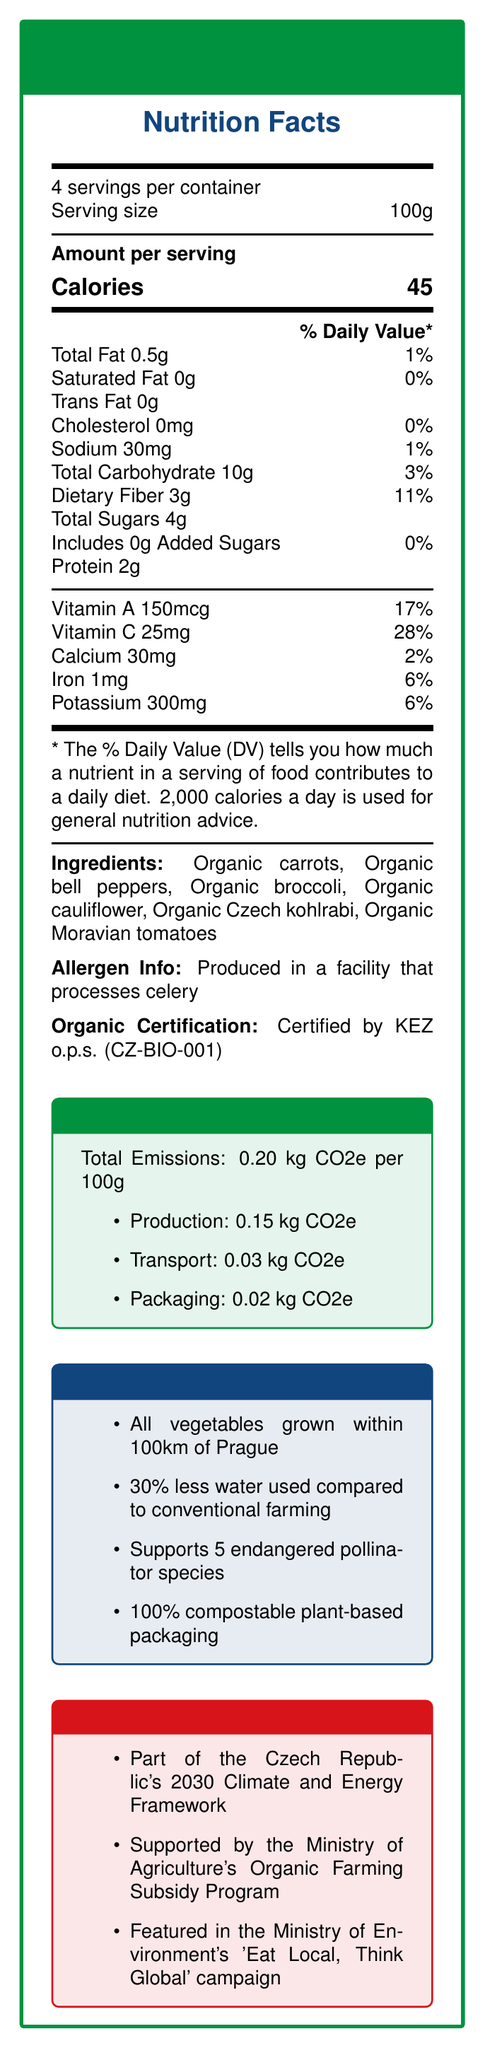what is the serving size for the Czech Eco-Friendly Vegetable Blend? The serving size is explicitly mentioned as 100g under the "4 servings per container" line.
Answer: 100g how many calories are there per serving? The calories per serving are mentioned as 45 in the "Amount per serving" section.
Answer: 45 list the vitamins and minerals provided by the vegetable blend and their respective daily values. The document lists these vitamins and minerals with their % Daily Values in the relevant section.
Answer: Vitamin A 17%, Vitamin C 28%, Calcium 2%, Iron 6%, Potassium 6% which organization certified the blend as organic? The "Organic Certification" information states that it is certified by KEZ o.p.s. (CZ-BIO-001).
Answer: KEZ o.p.s. (CZ-BIO-001) how much carbon dioxide equivalent (CO2e) emissions are produced from packaging per 100g? The "Carbon Footprint" section of the document states packaging emissions as 0.02 kg CO2e per 100g.
Answer: 0.02 kg CO2e what allergens are processed in the facility where the vegetable blend is produced? The "Allergen Info" section states that the product is produced in a facility that processes celery.
Answer: Celery how much dietary fiber is in one serving of the vegetable blend? The nutritional section lists dietary fiber as 3g per serving.
Answer: 3g what is the percentage of daily value for sodium in this product? The sodium percentage daily value listed in the document is 1%.
Answer: 1% how many servings are there in one container? The top section of the document states that there are 4 servings per container.
Answer: 4 which of the following vegetables are included as ingredients? A. Organic carrots, B. Organic broccoli, C. Organic spinach, D. Organic Czech kohlrabi, E. Organic cucumbers The ingredients list includes Organic carrots, Organic broccoli, and Organic Czech kohlrabi, but not spinach or cucumbers.
Answer: A, B, D how much less water does this vegetable blend use compared to conventional farming? The sustainability section states that 30% less water is used compared to conventional farming.
Answer: 30% less is this product part of any government initiatives? The document mentions that the product is part of several government initiatives, including the Czech Republic's 2030 Climate and Energy Framework, the Ministry of Agriculture's Organic Farming Subsidy Program, and the Ministry of Environment's 'Eat Local, Think Global' campaign.
Answer: Yes is this document about a locally-sourced organic fruit blend? The document is about a locally-sourced organic vegetable blend, not a fruit blend.
Answer: No what is the total amount of CO2e emissions for 100g of this product? The "Carbon Footprint" section lists the total emissions as 0.20 kg CO2e per 100g.
Answer: 0.20 kg CO2e summarize the main aspects of the document. The document covers nutritional facts, ingredients, allergen info, organic certification, carbon footprint data, sustainability practices, and government initiatives related to the vegetable blend.
Answer: The document provides nutritional information for a locally-sourced, organic vegetable blend called "Czech Eco-Friendly Vegetable Blend". It details the serving size, calories, and daily value percentages of various nutrients. It includes information on ingredients, allergen processing, and organic certification. The document also highlights the product's low carbon footprint, sustainability measures like local sourcing and water conservation, and its association with government initiatives promoting environmental responsibility. what is the daily value of trans fat in the vegetable blend? The nutritional information per serving indicates that the trans fat content is 0g, resulting in a daily value of 0%.
Answer: 0% what is the primary purpose of the 'Eat Local, Think Global' campaign? The document states that the vegetable blend is featured in the 'Eat Local, Think Global' campaign by the Ministry of Environment but does not provide details on the primary purpose of the campaign.
Answer: Not enough information 